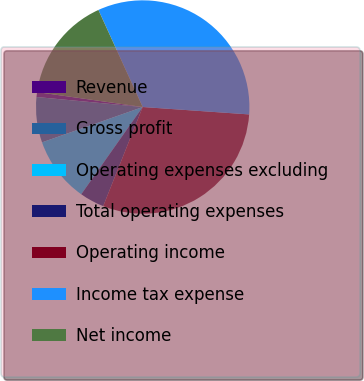Convert chart to OTSL. <chart><loc_0><loc_0><loc_500><loc_500><pie_chart><fcel>Revenue<fcel>Gross profit<fcel>Operating expenses excluding<fcel>Total operating expenses<fcel>Operating income<fcel>Income tax expense<fcel>Net income<nl><fcel>0.74%<fcel>6.87%<fcel>9.86%<fcel>3.73%<fcel>29.93%<fcel>32.92%<fcel>15.95%<nl></chart> 